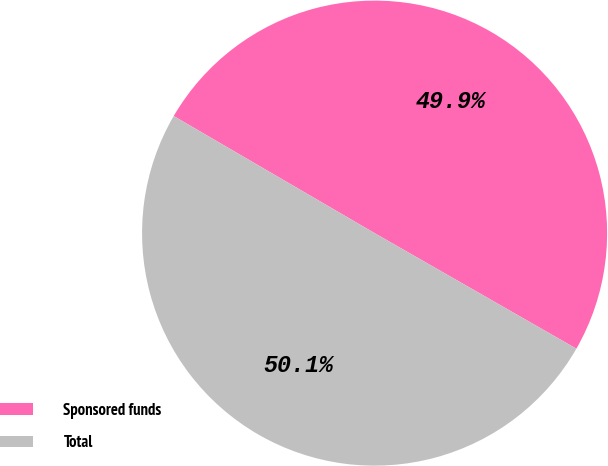<chart> <loc_0><loc_0><loc_500><loc_500><pie_chart><fcel>Sponsored funds<fcel>Total<nl><fcel>49.88%<fcel>50.12%<nl></chart> 